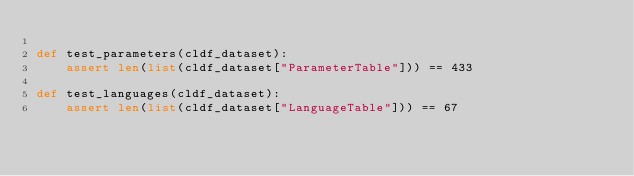<code> <loc_0><loc_0><loc_500><loc_500><_Python_>
def test_parameters(cldf_dataset):
    assert len(list(cldf_dataset["ParameterTable"])) == 433

def test_languages(cldf_dataset):
    assert len(list(cldf_dataset["LanguageTable"])) == 67
</code> 